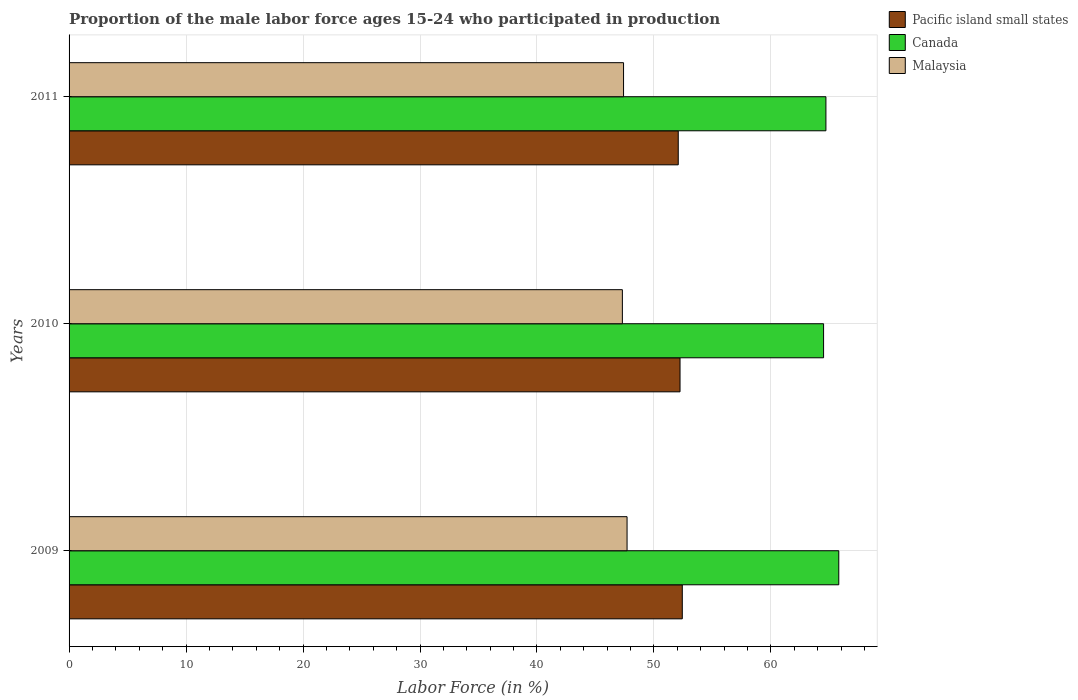Are the number of bars on each tick of the Y-axis equal?
Your response must be concise. Yes. What is the label of the 1st group of bars from the top?
Provide a short and direct response. 2011. In how many cases, is the number of bars for a given year not equal to the number of legend labels?
Your response must be concise. 0. What is the proportion of the male labor force who participated in production in Malaysia in 2010?
Keep it short and to the point. 47.3. Across all years, what is the maximum proportion of the male labor force who participated in production in Malaysia?
Offer a very short reply. 47.7. Across all years, what is the minimum proportion of the male labor force who participated in production in Malaysia?
Provide a short and direct response. 47.3. In which year was the proportion of the male labor force who participated in production in Pacific island small states minimum?
Your answer should be compact. 2011. What is the total proportion of the male labor force who participated in production in Pacific island small states in the graph?
Give a very brief answer. 156.73. What is the difference between the proportion of the male labor force who participated in production in Malaysia in 2009 and that in 2011?
Keep it short and to the point. 0.3. What is the difference between the proportion of the male labor force who participated in production in Canada in 2009 and the proportion of the male labor force who participated in production in Pacific island small states in 2011?
Make the answer very short. 13.72. What is the average proportion of the male labor force who participated in production in Pacific island small states per year?
Keep it short and to the point. 52.24. In the year 2011, what is the difference between the proportion of the male labor force who participated in production in Malaysia and proportion of the male labor force who participated in production in Canada?
Make the answer very short. -17.3. What is the ratio of the proportion of the male labor force who participated in production in Canada in 2010 to that in 2011?
Your answer should be very brief. 1. What is the difference between the highest and the second highest proportion of the male labor force who participated in production in Canada?
Your response must be concise. 1.1. What is the difference between the highest and the lowest proportion of the male labor force who participated in production in Canada?
Provide a short and direct response. 1.3. In how many years, is the proportion of the male labor force who participated in production in Malaysia greater than the average proportion of the male labor force who participated in production in Malaysia taken over all years?
Give a very brief answer. 1. Is the sum of the proportion of the male labor force who participated in production in Malaysia in 2009 and 2010 greater than the maximum proportion of the male labor force who participated in production in Pacific island small states across all years?
Give a very brief answer. Yes. What does the 3rd bar from the top in 2009 represents?
Your response must be concise. Pacific island small states. What does the 2nd bar from the bottom in 2010 represents?
Make the answer very short. Canada. Is it the case that in every year, the sum of the proportion of the male labor force who participated in production in Malaysia and proportion of the male labor force who participated in production in Pacific island small states is greater than the proportion of the male labor force who participated in production in Canada?
Your response must be concise. Yes. How many years are there in the graph?
Give a very brief answer. 3. Are the values on the major ticks of X-axis written in scientific E-notation?
Ensure brevity in your answer.  No. Where does the legend appear in the graph?
Keep it short and to the point. Top right. How many legend labels are there?
Your answer should be compact. 3. What is the title of the graph?
Provide a short and direct response. Proportion of the male labor force ages 15-24 who participated in production. What is the label or title of the X-axis?
Keep it short and to the point. Labor Force (in %). What is the label or title of the Y-axis?
Offer a terse response. Years. What is the Labor Force (in %) of Pacific island small states in 2009?
Offer a very short reply. 52.42. What is the Labor Force (in %) of Canada in 2009?
Keep it short and to the point. 65.8. What is the Labor Force (in %) in Malaysia in 2009?
Offer a terse response. 47.7. What is the Labor Force (in %) of Pacific island small states in 2010?
Ensure brevity in your answer.  52.23. What is the Labor Force (in %) in Canada in 2010?
Offer a terse response. 64.5. What is the Labor Force (in %) in Malaysia in 2010?
Provide a succinct answer. 47.3. What is the Labor Force (in %) of Pacific island small states in 2011?
Your response must be concise. 52.08. What is the Labor Force (in %) in Canada in 2011?
Your response must be concise. 64.7. What is the Labor Force (in %) in Malaysia in 2011?
Make the answer very short. 47.4. Across all years, what is the maximum Labor Force (in %) of Pacific island small states?
Offer a terse response. 52.42. Across all years, what is the maximum Labor Force (in %) of Canada?
Make the answer very short. 65.8. Across all years, what is the maximum Labor Force (in %) of Malaysia?
Provide a short and direct response. 47.7. Across all years, what is the minimum Labor Force (in %) of Pacific island small states?
Offer a terse response. 52.08. Across all years, what is the minimum Labor Force (in %) in Canada?
Provide a short and direct response. 64.5. Across all years, what is the minimum Labor Force (in %) of Malaysia?
Make the answer very short. 47.3. What is the total Labor Force (in %) in Pacific island small states in the graph?
Offer a terse response. 156.73. What is the total Labor Force (in %) in Canada in the graph?
Make the answer very short. 195. What is the total Labor Force (in %) in Malaysia in the graph?
Offer a terse response. 142.4. What is the difference between the Labor Force (in %) in Pacific island small states in 2009 and that in 2010?
Ensure brevity in your answer.  0.19. What is the difference between the Labor Force (in %) in Pacific island small states in 2009 and that in 2011?
Make the answer very short. 0.35. What is the difference between the Labor Force (in %) in Malaysia in 2009 and that in 2011?
Provide a succinct answer. 0.3. What is the difference between the Labor Force (in %) in Pacific island small states in 2010 and that in 2011?
Ensure brevity in your answer.  0.15. What is the difference between the Labor Force (in %) of Malaysia in 2010 and that in 2011?
Offer a very short reply. -0.1. What is the difference between the Labor Force (in %) of Pacific island small states in 2009 and the Labor Force (in %) of Canada in 2010?
Keep it short and to the point. -12.08. What is the difference between the Labor Force (in %) of Pacific island small states in 2009 and the Labor Force (in %) of Malaysia in 2010?
Ensure brevity in your answer.  5.12. What is the difference between the Labor Force (in %) of Pacific island small states in 2009 and the Labor Force (in %) of Canada in 2011?
Provide a succinct answer. -12.28. What is the difference between the Labor Force (in %) in Pacific island small states in 2009 and the Labor Force (in %) in Malaysia in 2011?
Your response must be concise. 5.02. What is the difference between the Labor Force (in %) of Canada in 2009 and the Labor Force (in %) of Malaysia in 2011?
Offer a very short reply. 18.4. What is the difference between the Labor Force (in %) in Pacific island small states in 2010 and the Labor Force (in %) in Canada in 2011?
Keep it short and to the point. -12.47. What is the difference between the Labor Force (in %) of Pacific island small states in 2010 and the Labor Force (in %) of Malaysia in 2011?
Your response must be concise. 4.83. What is the difference between the Labor Force (in %) of Canada in 2010 and the Labor Force (in %) of Malaysia in 2011?
Your response must be concise. 17.1. What is the average Labor Force (in %) in Pacific island small states per year?
Make the answer very short. 52.24. What is the average Labor Force (in %) of Malaysia per year?
Your response must be concise. 47.47. In the year 2009, what is the difference between the Labor Force (in %) of Pacific island small states and Labor Force (in %) of Canada?
Your answer should be very brief. -13.38. In the year 2009, what is the difference between the Labor Force (in %) of Pacific island small states and Labor Force (in %) of Malaysia?
Make the answer very short. 4.72. In the year 2010, what is the difference between the Labor Force (in %) in Pacific island small states and Labor Force (in %) in Canada?
Provide a succinct answer. -12.27. In the year 2010, what is the difference between the Labor Force (in %) in Pacific island small states and Labor Force (in %) in Malaysia?
Give a very brief answer. 4.93. In the year 2010, what is the difference between the Labor Force (in %) of Canada and Labor Force (in %) of Malaysia?
Your answer should be compact. 17.2. In the year 2011, what is the difference between the Labor Force (in %) in Pacific island small states and Labor Force (in %) in Canada?
Keep it short and to the point. -12.62. In the year 2011, what is the difference between the Labor Force (in %) of Pacific island small states and Labor Force (in %) of Malaysia?
Provide a short and direct response. 4.68. What is the ratio of the Labor Force (in %) of Pacific island small states in 2009 to that in 2010?
Offer a terse response. 1. What is the ratio of the Labor Force (in %) in Canada in 2009 to that in 2010?
Your answer should be very brief. 1.02. What is the ratio of the Labor Force (in %) of Malaysia in 2009 to that in 2010?
Give a very brief answer. 1.01. What is the ratio of the Labor Force (in %) of Malaysia in 2009 to that in 2011?
Provide a succinct answer. 1.01. What is the ratio of the Labor Force (in %) in Pacific island small states in 2010 to that in 2011?
Provide a succinct answer. 1. What is the difference between the highest and the second highest Labor Force (in %) of Pacific island small states?
Offer a terse response. 0.19. What is the difference between the highest and the second highest Labor Force (in %) of Canada?
Offer a very short reply. 1.1. What is the difference between the highest and the second highest Labor Force (in %) in Malaysia?
Give a very brief answer. 0.3. What is the difference between the highest and the lowest Labor Force (in %) in Pacific island small states?
Keep it short and to the point. 0.35. 